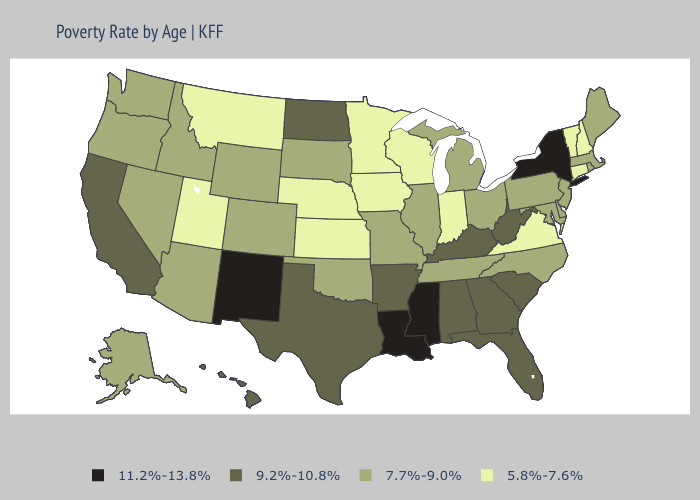Does Tennessee have the lowest value in the South?
Be succinct. No. Does Iowa have the highest value in the MidWest?
Be succinct. No. Does the map have missing data?
Write a very short answer. No. What is the value of Utah?
Quick response, please. 5.8%-7.6%. Among the states that border Indiana , does Kentucky have the highest value?
Short answer required. Yes. What is the highest value in states that border Nevada?
Give a very brief answer. 9.2%-10.8%. What is the value of Georgia?
Keep it brief. 9.2%-10.8%. Is the legend a continuous bar?
Write a very short answer. No. Does Iowa have the highest value in the USA?
Short answer required. No. Among the states that border Minnesota , which have the lowest value?
Answer briefly. Iowa, Wisconsin. What is the highest value in states that border Michigan?
Concise answer only. 7.7%-9.0%. How many symbols are there in the legend?
Quick response, please. 4. Which states hav the highest value in the MidWest?
Give a very brief answer. North Dakota. What is the value of Alaska?
Quick response, please. 7.7%-9.0%. Among the states that border Oklahoma , does Missouri have the lowest value?
Write a very short answer. No. 